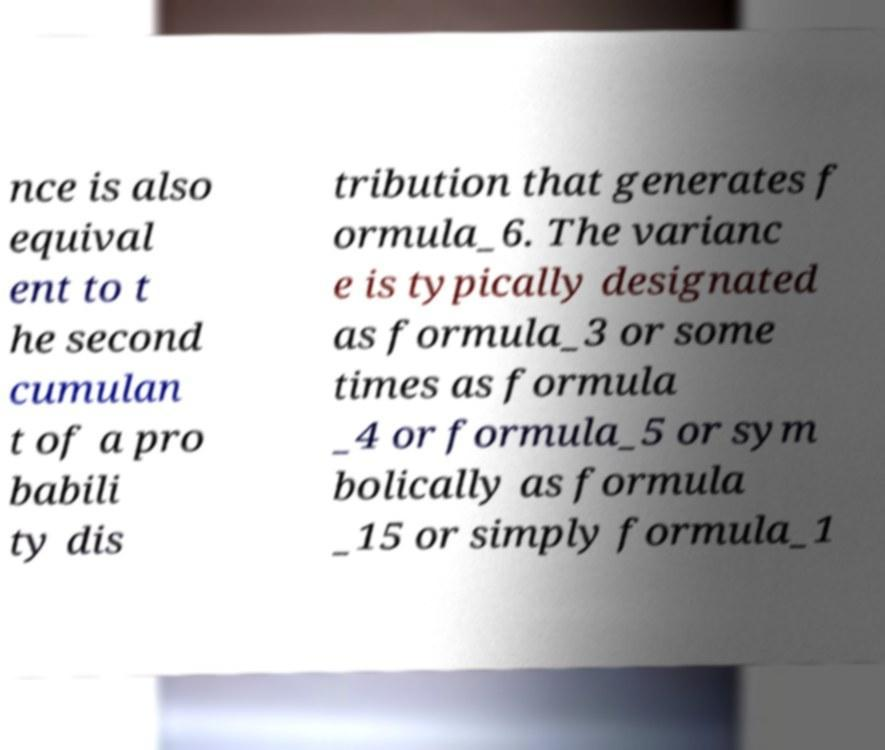Could you assist in decoding the text presented in this image and type it out clearly? nce is also equival ent to t he second cumulan t of a pro babili ty dis tribution that generates f ormula_6. The varianc e is typically designated as formula_3 or some times as formula _4 or formula_5 or sym bolically as formula _15 or simply formula_1 